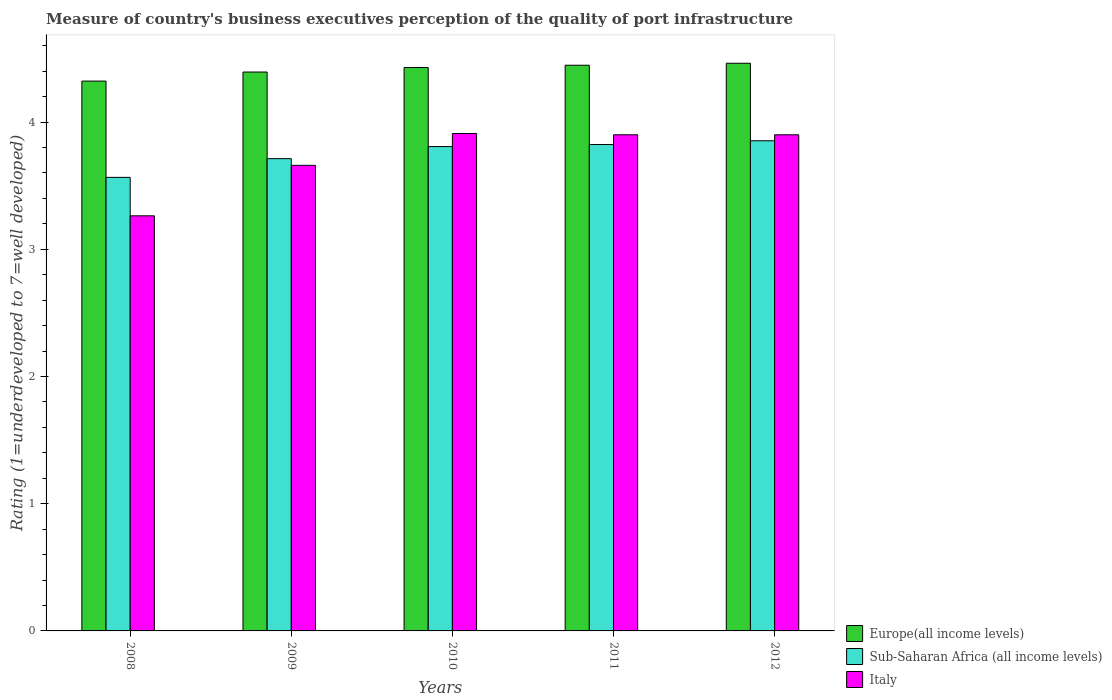How many groups of bars are there?
Offer a terse response. 5. Are the number of bars per tick equal to the number of legend labels?
Give a very brief answer. Yes. Are the number of bars on each tick of the X-axis equal?
Your answer should be very brief. Yes. In how many cases, is the number of bars for a given year not equal to the number of legend labels?
Your answer should be compact. 0. What is the ratings of the quality of port infrastructure in Europe(all income levels) in 2012?
Give a very brief answer. 4.46. Across all years, what is the maximum ratings of the quality of port infrastructure in Europe(all income levels)?
Offer a terse response. 4.46. Across all years, what is the minimum ratings of the quality of port infrastructure in Europe(all income levels)?
Ensure brevity in your answer.  4.32. In which year was the ratings of the quality of port infrastructure in Sub-Saharan Africa (all income levels) maximum?
Offer a very short reply. 2012. What is the total ratings of the quality of port infrastructure in Sub-Saharan Africa (all income levels) in the graph?
Offer a very short reply. 18.76. What is the difference between the ratings of the quality of port infrastructure in Italy in 2008 and that in 2012?
Your response must be concise. -0.64. What is the difference between the ratings of the quality of port infrastructure in Italy in 2008 and the ratings of the quality of port infrastructure in Europe(all income levels) in 2011?
Ensure brevity in your answer.  -1.18. What is the average ratings of the quality of port infrastructure in Europe(all income levels) per year?
Provide a succinct answer. 4.41. In the year 2010, what is the difference between the ratings of the quality of port infrastructure in Sub-Saharan Africa (all income levels) and ratings of the quality of port infrastructure in Europe(all income levels)?
Keep it short and to the point. -0.62. In how many years, is the ratings of the quality of port infrastructure in Sub-Saharan Africa (all income levels) greater than 3.6?
Ensure brevity in your answer.  4. What is the ratio of the ratings of the quality of port infrastructure in Italy in 2009 to that in 2010?
Keep it short and to the point. 0.94. Is the ratings of the quality of port infrastructure in Italy in 2008 less than that in 2012?
Your answer should be very brief. Yes. Is the difference between the ratings of the quality of port infrastructure in Sub-Saharan Africa (all income levels) in 2008 and 2010 greater than the difference between the ratings of the quality of port infrastructure in Europe(all income levels) in 2008 and 2010?
Make the answer very short. No. What is the difference between the highest and the second highest ratings of the quality of port infrastructure in Europe(all income levels)?
Your answer should be compact. 0.02. What is the difference between the highest and the lowest ratings of the quality of port infrastructure in Europe(all income levels)?
Offer a very short reply. 0.14. In how many years, is the ratings of the quality of port infrastructure in Italy greater than the average ratings of the quality of port infrastructure in Italy taken over all years?
Your response must be concise. 3. Is the sum of the ratings of the quality of port infrastructure in Europe(all income levels) in 2009 and 2012 greater than the maximum ratings of the quality of port infrastructure in Italy across all years?
Provide a short and direct response. Yes. What does the 3rd bar from the left in 2010 represents?
Ensure brevity in your answer.  Italy. Is it the case that in every year, the sum of the ratings of the quality of port infrastructure in Europe(all income levels) and ratings of the quality of port infrastructure in Italy is greater than the ratings of the quality of port infrastructure in Sub-Saharan Africa (all income levels)?
Give a very brief answer. Yes. Are the values on the major ticks of Y-axis written in scientific E-notation?
Offer a very short reply. No. Does the graph contain grids?
Your answer should be very brief. No. Where does the legend appear in the graph?
Your answer should be very brief. Bottom right. How many legend labels are there?
Ensure brevity in your answer.  3. What is the title of the graph?
Ensure brevity in your answer.  Measure of country's business executives perception of the quality of port infrastructure. What is the label or title of the X-axis?
Your answer should be very brief. Years. What is the label or title of the Y-axis?
Your answer should be very brief. Rating (1=underdeveloped to 7=well developed). What is the Rating (1=underdeveloped to 7=well developed) of Europe(all income levels) in 2008?
Your response must be concise. 4.32. What is the Rating (1=underdeveloped to 7=well developed) in Sub-Saharan Africa (all income levels) in 2008?
Give a very brief answer. 3.57. What is the Rating (1=underdeveloped to 7=well developed) of Italy in 2008?
Your response must be concise. 3.26. What is the Rating (1=underdeveloped to 7=well developed) of Europe(all income levels) in 2009?
Give a very brief answer. 4.39. What is the Rating (1=underdeveloped to 7=well developed) of Sub-Saharan Africa (all income levels) in 2009?
Your answer should be very brief. 3.71. What is the Rating (1=underdeveloped to 7=well developed) in Italy in 2009?
Your response must be concise. 3.66. What is the Rating (1=underdeveloped to 7=well developed) of Europe(all income levels) in 2010?
Your answer should be compact. 4.43. What is the Rating (1=underdeveloped to 7=well developed) of Sub-Saharan Africa (all income levels) in 2010?
Your response must be concise. 3.81. What is the Rating (1=underdeveloped to 7=well developed) in Italy in 2010?
Give a very brief answer. 3.91. What is the Rating (1=underdeveloped to 7=well developed) in Europe(all income levels) in 2011?
Offer a terse response. 4.45. What is the Rating (1=underdeveloped to 7=well developed) of Sub-Saharan Africa (all income levels) in 2011?
Your answer should be very brief. 3.82. What is the Rating (1=underdeveloped to 7=well developed) of Italy in 2011?
Give a very brief answer. 3.9. What is the Rating (1=underdeveloped to 7=well developed) of Europe(all income levels) in 2012?
Give a very brief answer. 4.46. What is the Rating (1=underdeveloped to 7=well developed) in Sub-Saharan Africa (all income levels) in 2012?
Provide a short and direct response. 3.85. Across all years, what is the maximum Rating (1=underdeveloped to 7=well developed) of Europe(all income levels)?
Your answer should be very brief. 4.46. Across all years, what is the maximum Rating (1=underdeveloped to 7=well developed) in Sub-Saharan Africa (all income levels)?
Your answer should be compact. 3.85. Across all years, what is the maximum Rating (1=underdeveloped to 7=well developed) of Italy?
Your response must be concise. 3.91. Across all years, what is the minimum Rating (1=underdeveloped to 7=well developed) of Europe(all income levels)?
Your response must be concise. 4.32. Across all years, what is the minimum Rating (1=underdeveloped to 7=well developed) in Sub-Saharan Africa (all income levels)?
Provide a short and direct response. 3.57. Across all years, what is the minimum Rating (1=underdeveloped to 7=well developed) in Italy?
Make the answer very short. 3.26. What is the total Rating (1=underdeveloped to 7=well developed) in Europe(all income levels) in the graph?
Offer a terse response. 22.05. What is the total Rating (1=underdeveloped to 7=well developed) in Sub-Saharan Africa (all income levels) in the graph?
Your answer should be very brief. 18.76. What is the total Rating (1=underdeveloped to 7=well developed) of Italy in the graph?
Provide a succinct answer. 18.63. What is the difference between the Rating (1=underdeveloped to 7=well developed) in Europe(all income levels) in 2008 and that in 2009?
Your answer should be compact. -0.07. What is the difference between the Rating (1=underdeveloped to 7=well developed) of Sub-Saharan Africa (all income levels) in 2008 and that in 2009?
Provide a succinct answer. -0.15. What is the difference between the Rating (1=underdeveloped to 7=well developed) in Italy in 2008 and that in 2009?
Your response must be concise. -0.4. What is the difference between the Rating (1=underdeveloped to 7=well developed) of Europe(all income levels) in 2008 and that in 2010?
Keep it short and to the point. -0.11. What is the difference between the Rating (1=underdeveloped to 7=well developed) of Sub-Saharan Africa (all income levels) in 2008 and that in 2010?
Ensure brevity in your answer.  -0.24. What is the difference between the Rating (1=underdeveloped to 7=well developed) of Italy in 2008 and that in 2010?
Provide a short and direct response. -0.65. What is the difference between the Rating (1=underdeveloped to 7=well developed) of Europe(all income levels) in 2008 and that in 2011?
Your response must be concise. -0.12. What is the difference between the Rating (1=underdeveloped to 7=well developed) in Sub-Saharan Africa (all income levels) in 2008 and that in 2011?
Ensure brevity in your answer.  -0.26. What is the difference between the Rating (1=underdeveloped to 7=well developed) in Italy in 2008 and that in 2011?
Your answer should be very brief. -0.64. What is the difference between the Rating (1=underdeveloped to 7=well developed) of Europe(all income levels) in 2008 and that in 2012?
Your answer should be compact. -0.14. What is the difference between the Rating (1=underdeveloped to 7=well developed) of Sub-Saharan Africa (all income levels) in 2008 and that in 2012?
Your answer should be very brief. -0.29. What is the difference between the Rating (1=underdeveloped to 7=well developed) in Italy in 2008 and that in 2012?
Provide a succinct answer. -0.64. What is the difference between the Rating (1=underdeveloped to 7=well developed) in Europe(all income levels) in 2009 and that in 2010?
Provide a short and direct response. -0.04. What is the difference between the Rating (1=underdeveloped to 7=well developed) of Sub-Saharan Africa (all income levels) in 2009 and that in 2010?
Keep it short and to the point. -0.09. What is the difference between the Rating (1=underdeveloped to 7=well developed) in Italy in 2009 and that in 2010?
Give a very brief answer. -0.25. What is the difference between the Rating (1=underdeveloped to 7=well developed) of Europe(all income levels) in 2009 and that in 2011?
Provide a short and direct response. -0.05. What is the difference between the Rating (1=underdeveloped to 7=well developed) in Sub-Saharan Africa (all income levels) in 2009 and that in 2011?
Your answer should be compact. -0.11. What is the difference between the Rating (1=underdeveloped to 7=well developed) of Italy in 2009 and that in 2011?
Ensure brevity in your answer.  -0.24. What is the difference between the Rating (1=underdeveloped to 7=well developed) in Europe(all income levels) in 2009 and that in 2012?
Offer a very short reply. -0.07. What is the difference between the Rating (1=underdeveloped to 7=well developed) of Sub-Saharan Africa (all income levels) in 2009 and that in 2012?
Your answer should be very brief. -0.14. What is the difference between the Rating (1=underdeveloped to 7=well developed) of Italy in 2009 and that in 2012?
Offer a terse response. -0.24. What is the difference between the Rating (1=underdeveloped to 7=well developed) in Europe(all income levels) in 2010 and that in 2011?
Offer a terse response. -0.02. What is the difference between the Rating (1=underdeveloped to 7=well developed) in Sub-Saharan Africa (all income levels) in 2010 and that in 2011?
Ensure brevity in your answer.  -0.02. What is the difference between the Rating (1=underdeveloped to 7=well developed) in Italy in 2010 and that in 2011?
Provide a succinct answer. 0.01. What is the difference between the Rating (1=underdeveloped to 7=well developed) of Europe(all income levels) in 2010 and that in 2012?
Your answer should be compact. -0.03. What is the difference between the Rating (1=underdeveloped to 7=well developed) of Sub-Saharan Africa (all income levels) in 2010 and that in 2012?
Make the answer very short. -0.05. What is the difference between the Rating (1=underdeveloped to 7=well developed) of Italy in 2010 and that in 2012?
Your answer should be very brief. 0.01. What is the difference between the Rating (1=underdeveloped to 7=well developed) in Europe(all income levels) in 2011 and that in 2012?
Give a very brief answer. -0.02. What is the difference between the Rating (1=underdeveloped to 7=well developed) of Sub-Saharan Africa (all income levels) in 2011 and that in 2012?
Keep it short and to the point. -0.03. What is the difference between the Rating (1=underdeveloped to 7=well developed) of Europe(all income levels) in 2008 and the Rating (1=underdeveloped to 7=well developed) of Sub-Saharan Africa (all income levels) in 2009?
Your response must be concise. 0.61. What is the difference between the Rating (1=underdeveloped to 7=well developed) in Europe(all income levels) in 2008 and the Rating (1=underdeveloped to 7=well developed) in Italy in 2009?
Give a very brief answer. 0.66. What is the difference between the Rating (1=underdeveloped to 7=well developed) in Sub-Saharan Africa (all income levels) in 2008 and the Rating (1=underdeveloped to 7=well developed) in Italy in 2009?
Your answer should be very brief. -0.09. What is the difference between the Rating (1=underdeveloped to 7=well developed) of Europe(all income levels) in 2008 and the Rating (1=underdeveloped to 7=well developed) of Sub-Saharan Africa (all income levels) in 2010?
Keep it short and to the point. 0.51. What is the difference between the Rating (1=underdeveloped to 7=well developed) in Europe(all income levels) in 2008 and the Rating (1=underdeveloped to 7=well developed) in Italy in 2010?
Ensure brevity in your answer.  0.41. What is the difference between the Rating (1=underdeveloped to 7=well developed) of Sub-Saharan Africa (all income levels) in 2008 and the Rating (1=underdeveloped to 7=well developed) of Italy in 2010?
Your answer should be compact. -0.34. What is the difference between the Rating (1=underdeveloped to 7=well developed) of Europe(all income levels) in 2008 and the Rating (1=underdeveloped to 7=well developed) of Sub-Saharan Africa (all income levels) in 2011?
Your answer should be very brief. 0.5. What is the difference between the Rating (1=underdeveloped to 7=well developed) of Europe(all income levels) in 2008 and the Rating (1=underdeveloped to 7=well developed) of Italy in 2011?
Provide a succinct answer. 0.42. What is the difference between the Rating (1=underdeveloped to 7=well developed) in Sub-Saharan Africa (all income levels) in 2008 and the Rating (1=underdeveloped to 7=well developed) in Italy in 2011?
Give a very brief answer. -0.33. What is the difference between the Rating (1=underdeveloped to 7=well developed) of Europe(all income levels) in 2008 and the Rating (1=underdeveloped to 7=well developed) of Sub-Saharan Africa (all income levels) in 2012?
Your answer should be compact. 0.47. What is the difference between the Rating (1=underdeveloped to 7=well developed) of Europe(all income levels) in 2008 and the Rating (1=underdeveloped to 7=well developed) of Italy in 2012?
Your response must be concise. 0.42. What is the difference between the Rating (1=underdeveloped to 7=well developed) in Sub-Saharan Africa (all income levels) in 2008 and the Rating (1=underdeveloped to 7=well developed) in Italy in 2012?
Your answer should be compact. -0.33. What is the difference between the Rating (1=underdeveloped to 7=well developed) of Europe(all income levels) in 2009 and the Rating (1=underdeveloped to 7=well developed) of Sub-Saharan Africa (all income levels) in 2010?
Offer a terse response. 0.59. What is the difference between the Rating (1=underdeveloped to 7=well developed) in Europe(all income levels) in 2009 and the Rating (1=underdeveloped to 7=well developed) in Italy in 2010?
Give a very brief answer. 0.48. What is the difference between the Rating (1=underdeveloped to 7=well developed) of Sub-Saharan Africa (all income levels) in 2009 and the Rating (1=underdeveloped to 7=well developed) of Italy in 2010?
Your answer should be compact. -0.2. What is the difference between the Rating (1=underdeveloped to 7=well developed) in Europe(all income levels) in 2009 and the Rating (1=underdeveloped to 7=well developed) in Sub-Saharan Africa (all income levels) in 2011?
Give a very brief answer. 0.57. What is the difference between the Rating (1=underdeveloped to 7=well developed) in Europe(all income levels) in 2009 and the Rating (1=underdeveloped to 7=well developed) in Italy in 2011?
Your answer should be compact. 0.49. What is the difference between the Rating (1=underdeveloped to 7=well developed) in Sub-Saharan Africa (all income levels) in 2009 and the Rating (1=underdeveloped to 7=well developed) in Italy in 2011?
Provide a succinct answer. -0.19. What is the difference between the Rating (1=underdeveloped to 7=well developed) of Europe(all income levels) in 2009 and the Rating (1=underdeveloped to 7=well developed) of Sub-Saharan Africa (all income levels) in 2012?
Keep it short and to the point. 0.54. What is the difference between the Rating (1=underdeveloped to 7=well developed) in Europe(all income levels) in 2009 and the Rating (1=underdeveloped to 7=well developed) in Italy in 2012?
Give a very brief answer. 0.49. What is the difference between the Rating (1=underdeveloped to 7=well developed) in Sub-Saharan Africa (all income levels) in 2009 and the Rating (1=underdeveloped to 7=well developed) in Italy in 2012?
Offer a very short reply. -0.19. What is the difference between the Rating (1=underdeveloped to 7=well developed) in Europe(all income levels) in 2010 and the Rating (1=underdeveloped to 7=well developed) in Sub-Saharan Africa (all income levels) in 2011?
Your response must be concise. 0.61. What is the difference between the Rating (1=underdeveloped to 7=well developed) in Europe(all income levels) in 2010 and the Rating (1=underdeveloped to 7=well developed) in Italy in 2011?
Your response must be concise. 0.53. What is the difference between the Rating (1=underdeveloped to 7=well developed) of Sub-Saharan Africa (all income levels) in 2010 and the Rating (1=underdeveloped to 7=well developed) of Italy in 2011?
Give a very brief answer. -0.09. What is the difference between the Rating (1=underdeveloped to 7=well developed) in Europe(all income levels) in 2010 and the Rating (1=underdeveloped to 7=well developed) in Sub-Saharan Africa (all income levels) in 2012?
Provide a short and direct response. 0.58. What is the difference between the Rating (1=underdeveloped to 7=well developed) in Europe(all income levels) in 2010 and the Rating (1=underdeveloped to 7=well developed) in Italy in 2012?
Ensure brevity in your answer.  0.53. What is the difference between the Rating (1=underdeveloped to 7=well developed) of Sub-Saharan Africa (all income levels) in 2010 and the Rating (1=underdeveloped to 7=well developed) of Italy in 2012?
Offer a terse response. -0.09. What is the difference between the Rating (1=underdeveloped to 7=well developed) in Europe(all income levels) in 2011 and the Rating (1=underdeveloped to 7=well developed) in Sub-Saharan Africa (all income levels) in 2012?
Your answer should be very brief. 0.59. What is the difference between the Rating (1=underdeveloped to 7=well developed) in Europe(all income levels) in 2011 and the Rating (1=underdeveloped to 7=well developed) in Italy in 2012?
Keep it short and to the point. 0.55. What is the difference between the Rating (1=underdeveloped to 7=well developed) of Sub-Saharan Africa (all income levels) in 2011 and the Rating (1=underdeveloped to 7=well developed) of Italy in 2012?
Ensure brevity in your answer.  -0.08. What is the average Rating (1=underdeveloped to 7=well developed) of Europe(all income levels) per year?
Make the answer very short. 4.41. What is the average Rating (1=underdeveloped to 7=well developed) in Sub-Saharan Africa (all income levels) per year?
Ensure brevity in your answer.  3.75. What is the average Rating (1=underdeveloped to 7=well developed) of Italy per year?
Make the answer very short. 3.73. In the year 2008, what is the difference between the Rating (1=underdeveloped to 7=well developed) of Europe(all income levels) and Rating (1=underdeveloped to 7=well developed) of Sub-Saharan Africa (all income levels)?
Make the answer very short. 0.76. In the year 2008, what is the difference between the Rating (1=underdeveloped to 7=well developed) in Europe(all income levels) and Rating (1=underdeveloped to 7=well developed) in Italy?
Ensure brevity in your answer.  1.06. In the year 2008, what is the difference between the Rating (1=underdeveloped to 7=well developed) of Sub-Saharan Africa (all income levels) and Rating (1=underdeveloped to 7=well developed) of Italy?
Your answer should be compact. 0.3. In the year 2009, what is the difference between the Rating (1=underdeveloped to 7=well developed) of Europe(all income levels) and Rating (1=underdeveloped to 7=well developed) of Sub-Saharan Africa (all income levels)?
Offer a terse response. 0.68. In the year 2009, what is the difference between the Rating (1=underdeveloped to 7=well developed) of Europe(all income levels) and Rating (1=underdeveloped to 7=well developed) of Italy?
Ensure brevity in your answer.  0.73. In the year 2009, what is the difference between the Rating (1=underdeveloped to 7=well developed) of Sub-Saharan Africa (all income levels) and Rating (1=underdeveloped to 7=well developed) of Italy?
Your answer should be very brief. 0.05. In the year 2010, what is the difference between the Rating (1=underdeveloped to 7=well developed) of Europe(all income levels) and Rating (1=underdeveloped to 7=well developed) of Sub-Saharan Africa (all income levels)?
Give a very brief answer. 0.62. In the year 2010, what is the difference between the Rating (1=underdeveloped to 7=well developed) in Europe(all income levels) and Rating (1=underdeveloped to 7=well developed) in Italy?
Keep it short and to the point. 0.52. In the year 2010, what is the difference between the Rating (1=underdeveloped to 7=well developed) in Sub-Saharan Africa (all income levels) and Rating (1=underdeveloped to 7=well developed) in Italy?
Provide a succinct answer. -0.1. In the year 2011, what is the difference between the Rating (1=underdeveloped to 7=well developed) of Europe(all income levels) and Rating (1=underdeveloped to 7=well developed) of Sub-Saharan Africa (all income levels)?
Your answer should be very brief. 0.62. In the year 2011, what is the difference between the Rating (1=underdeveloped to 7=well developed) of Europe(all income levels) and Rating (1=underdeveloped to 7=well developed) of Italy?
Make the answer very short. 0.55. In the year 2011, what is the difference between the Rating (1=underdeveloped to 7=well developed) of Sub-Saharan Africa (all income levels) and Rating (1=underdeveloped to 7=well developed) of Italy?
Provide a succinct answer. -0.08. In the year 2012, what is the difference between the Rating (1=underdeveloped to 7=well developed) of Europe(all income levels) and Rating (1=underdeveloped to 7=well developed) of Sub-Saharan Africa (all income levels)?
Make the answer very short. 0.61. In the year 2012, what is the difference between the Rating (1=underdeveloped to 7=well developed) of Europe(all income levels) and Rating (1=underdeveloped to 7=well developed) of Italy?
Keep it short and to the point. 0.56. In the year 2012, what is the difference between the Rating (1=underdeveloped to 7=well developed) of Sub-Saharan Africa (all income levels) and Rating (1=underdeveloped to 7=well developed) of Italy?
Provide a short and direct response. -0.05. What is the ratio of the Rating (1=underdeveloped to 7=well developed) in Europe(all income levels) in 2008 to that in 2009?
Your answer should be very brief. 0.98. What is the ratio of the Rating (1=underdeveloped to 7=well developed) of Sub-Saharan Africa (all income levels) in 2008 to that in 2009?
Offer a terse response. 0.96. What is the ratio of the Rating (1=underdeveloped to 7=well developed) in Italy in 2008 to that in 2009?
Your response must be concise. 0.89. What is the ratio of the Rating (1=underdeveloped to 7=well developed) in Europe(all income levels) in 2008 to that in 2010?
Make the answer very short. 0.98. What is the ratio of the Rating (1=underdeveloped to 7=well developed) in Sub-Saharan Africa (all income levels) in 2008 to that in 2010?
Your answer should be very brief. 0.94. What is the ratio of the Rating (1=underdeveloped to 7=well developed) in Italy in 2008 to that in 2010?
Provide a short and direct response. 0.83. What is the ratio of the Rating (1=underdeveloped to 7=well developed) in Europe(all income levels) in 2008 to that in 2011?
Ensure brevity in your answer.  0.97. What is the ratio of the Rating (1=underdeveloped to 7=well developed) in Sub-Saharan Africa (all income levels) in 2008 to that in 2011?
Give a very brief answer. 0.93. What is the ratio of the Rating (1=underdeveloped to 7=well developed) of Italy in 2008 to that in 2011?
Provide a succinct answer. 0.84. What is the ratio of the Rating (1=underdeveloped to 7=well developed) of Europe(all income levels) in 2008 to that in 2012?
Your answer should be very brief. 0.97. What is the ratio of the Rating (1=underdeveloped to 7=well developed) in Sub-Saharan Africa (all income levels) in 2008 to that in 2012?
Provide a succinct answer. 0.93. What is the ratio of the Rating (1=underdeveloped to 7=well developed) in Italy in 2008 to that in 2012?
Ensure brevity in your answer.  0.84. What is the ratio of the Rating (1=underdeveloped to 7=well developed) of Sub-Saharan Africa (all income levels) in 2009 to that in 2010?
Keep it short and to the point. 0.98. What is the ratio of the Rating (1=underdeveloped to 7=well developed) of Italy in 2009 to that in 2010?
Offer a terse response. 0.94. What is the ratio of the Rating (1=underdeveloped to 7=well developed) of Sub-Saharan Africa (all income levels) in 2009 to that in 2011?
Your answer should be very brief. 0.97. What is the ratio of the Rating (1=underdeveloped to 7=well developed) in Italy in 2009 to that in 2011?
Offer a terse response. 0.94. What is the ratio of the Rating (1=underdeveloped to 7=well developed) in Europe(all income levels) in 2009 to that in 2012?
Your response must be concise. 0.98. What is the ratio of the Rating (1=underdeveloped to 7=well developed) of Sub-Saharan Africa (all income levels) in 2009 to that in 2012?
Offer a very short reply. 0.96. What is the ratio of the Rating (1=underdeveloped to 7=well developed) in Italy in 2009 to that in 2012?
Give a very brief answer. 0.94. What is the ratio of the Rating (1=underdeveloped to 7=well developed) of Sub-Saharan Africa (all income levels) in 2010 to that in 2011?
Your answer should be very brief. 1. What is the ratio of the Rating (1=underdeveloped to 7=well developed) of Italy in 2010 to that in 2011?
Offer a terse response. 1. What is the ratio of the Rating (1=underdeveloped to 7=well developed) in Sub-Saharan Africa (all income levels) in 2010 to that in 2012?
Keep it short and to the point. 0.99. What is the ratio of the Rating (1=underdeveloped to 7=well developed) in Italy in 2010 to that in 2012?
Your response must be concise. 1. What is the ratio of the Rating (1=underdeveloped to 7=well developed) of Europe(all income levels) in 2011 to that in 2012?
Your answer should be very brief. 1. What is the ratio of the Rating (1=underdeveloped to 7=well developed) in Italy in 2011 to that in 2012?
Offer a very short reply. 1. What is the difference between the highest and the second highest Rating (1=underdeveloped to 7=well developed) of Europe(all income levels)?
Your answer should be very brief. 0.02. What is the difference between the highest and the second highest Rating (1=underdeveloped to 7=well developed) in Sub-Saharan Africa (all income levels)?
Provide a succinct answer. 0.03. What is the difference between the highest and the second highest Rating (1=underdeveloped to 7=well developed) of Italy?
Offer a terse response. 0.01. What is the difference between the highest and the lowest Rating (1=underdeveloped to 7=well developed) of Europe(all income levels)?
Give a very brief answer. 0.14. What is the difference between the highest and the lowest Rating (1=underdeveloped to 7=well developed) of Sub-Saharan Africa (all income levels)?
Provide a succinct answer. 0.29. What is the difference between the highest and the lowest Rating (1=underdeveloped to 7=well developed) in Italy?
Provide a short and direct response. 0.65. 